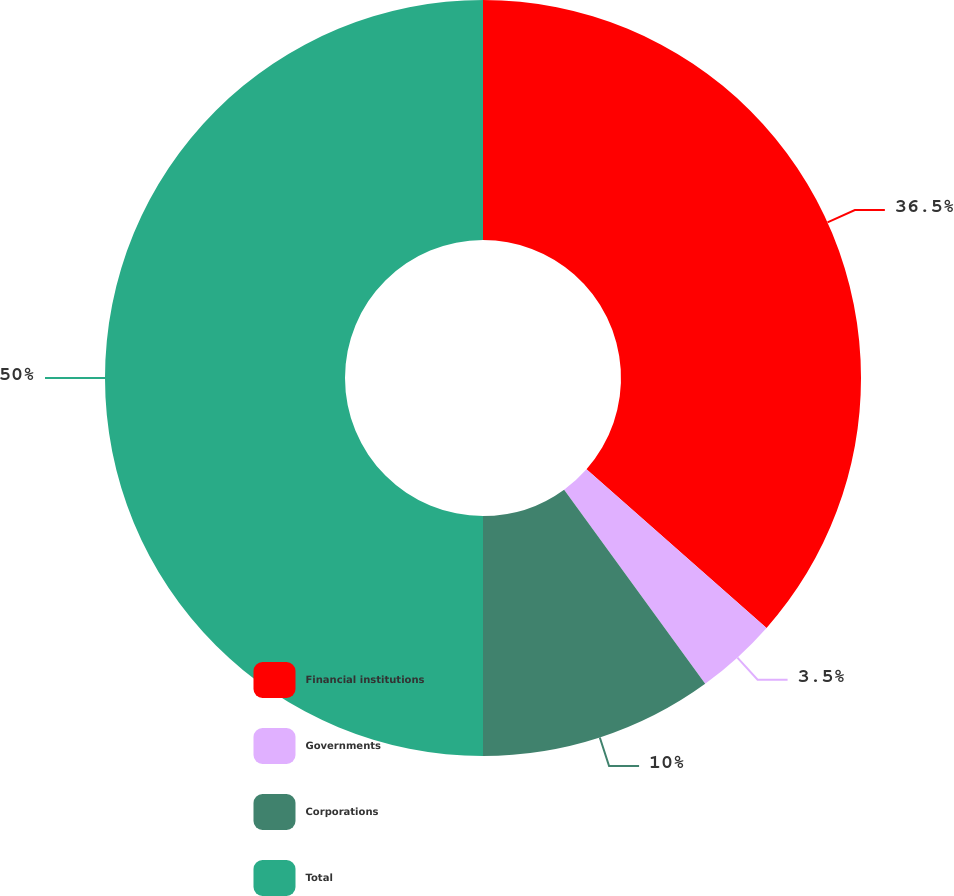Convert chart to OTSL. <chart><loc_0><loc_0><loc_500><loc_500><pie_chart><fcel>Financial institutions<fcel>Governments<fcel>Corporations<fcel>Total<nl><fcel>36.5%<fcel>3.5%<fcel>10.0%<fcel>50.0%<nl></chart> 